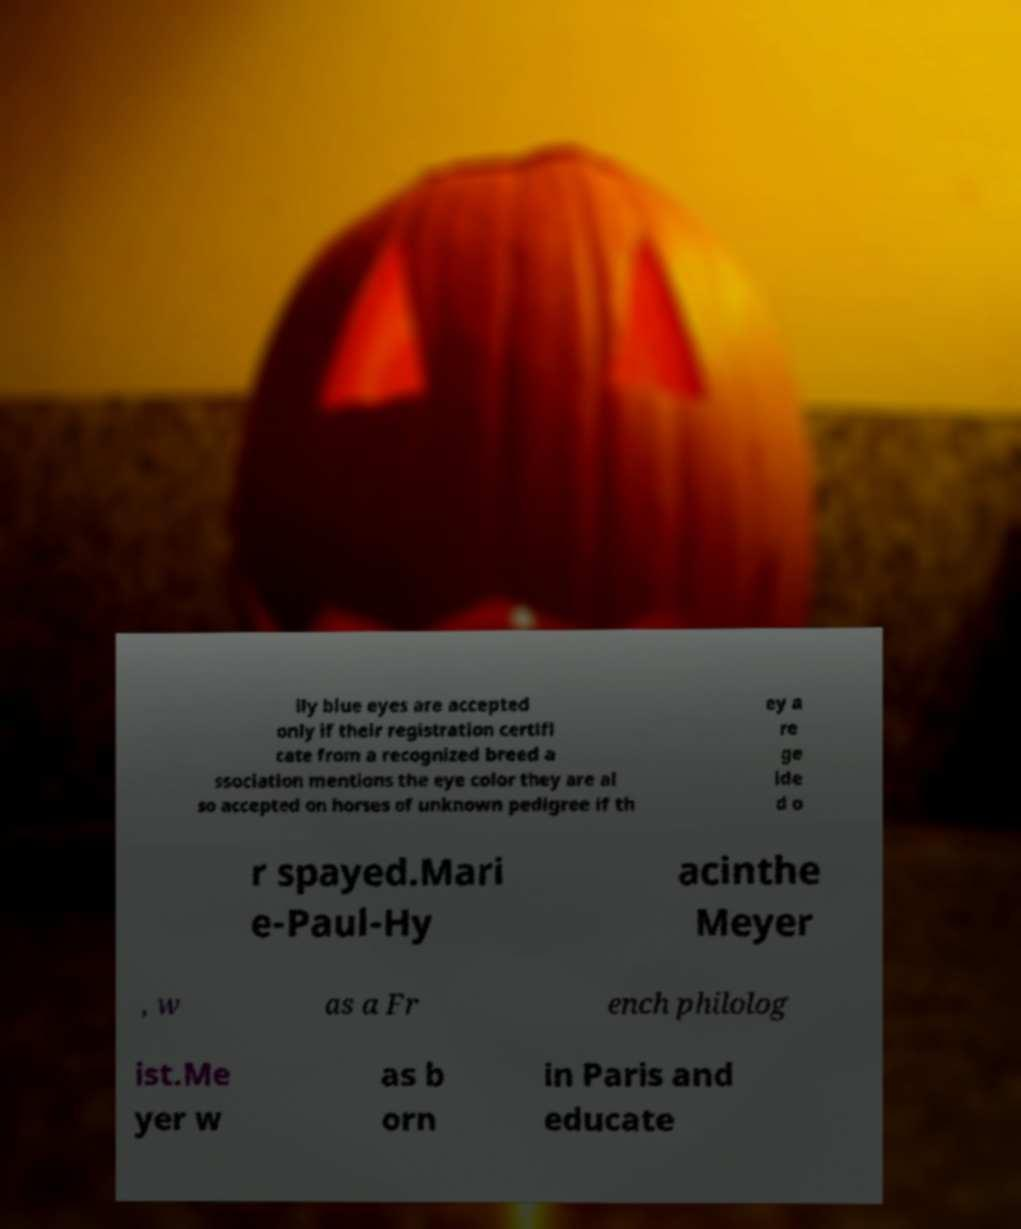For documentation purposes, I need the text within this image transcribed. Could you provide that? lly blue eyes are accepted only if their registration certifi cate from a recognized breed a ssociation mentions the eye color they are al so accepted on horses of unknown pedigree if th ey a re ge lde d o r spayed.Mari e-Paul-Hy acinthe Meyer , w as a Fr ench philolog ist.Me yer w as b orn in Paris and educate 